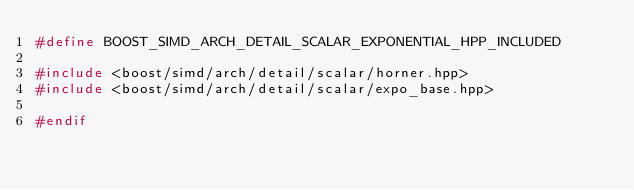Convert code to text. <code><loc_0><loc_0><loc_500><loc_500><_C++_>#define BOOST_SIMD_ARCH_DETAIL_SCALAR_EXPONENTIAL_HPP_INCLUDED

#include <boost/simd/arch/detail/scalar/horner.hpp>
#include <boost/simd/arch/detail/scalar/expo_base.hpp>

#endif

</code> 